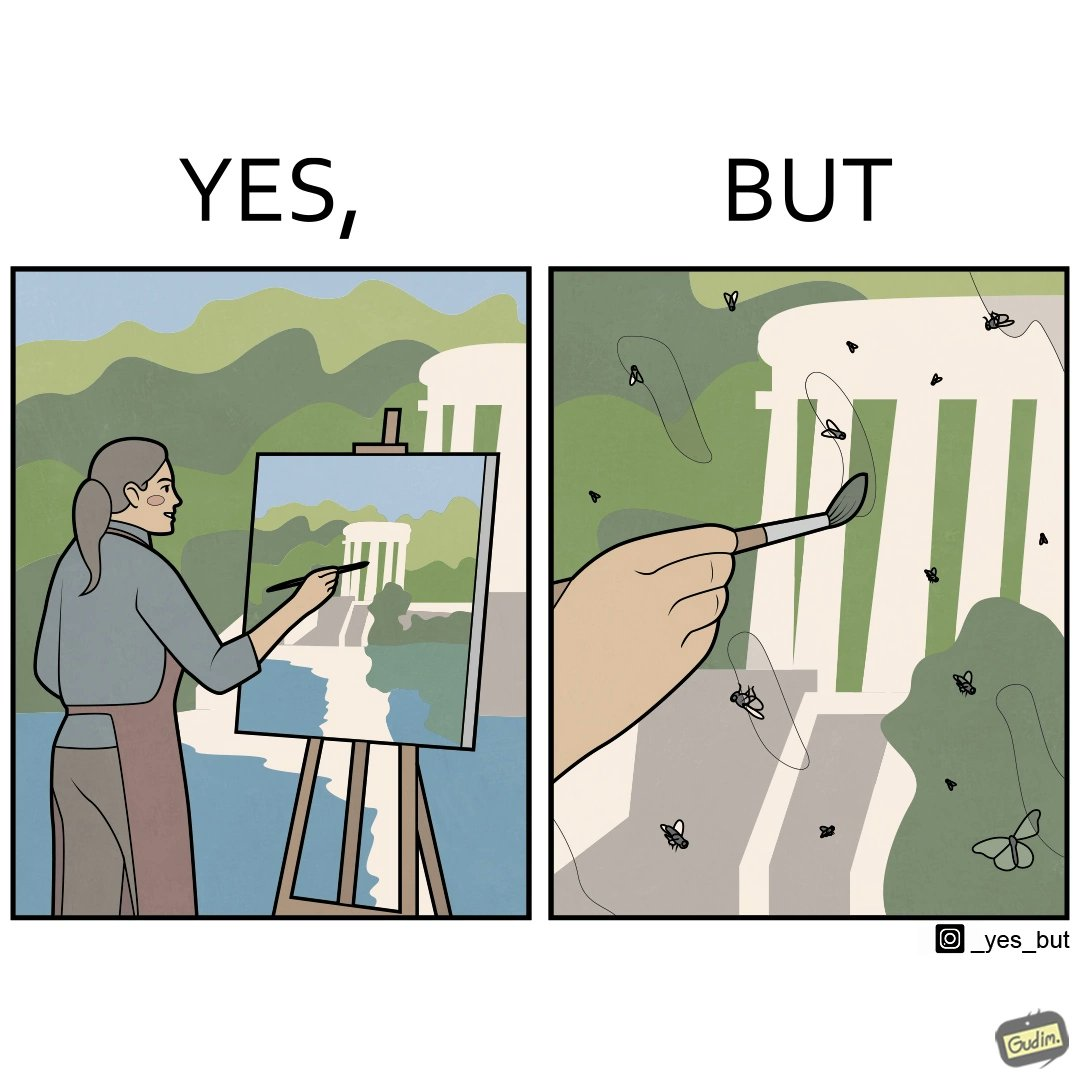What does this image depict? The images are funny since they show how a peaceful sight like a woman painting a natural scenery looks good only from afar. When looked closely we can see details like flies on the painting which make us uneasy and the scene is not so good to look at anymore. 